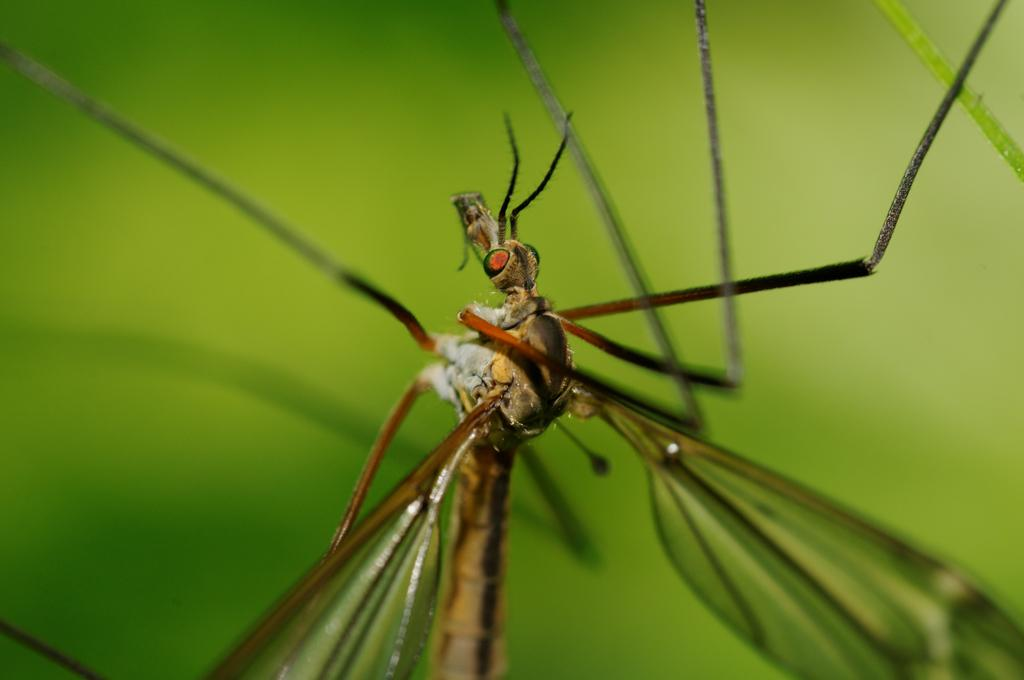What type of creature can be seen in the image? There is an insect in the image. What color is the background of the image? The background of the image is green. What type of feather can be seen on the insect in the image? There is no feather present on the insect in the image. What flavor does the insect have in the image? Insects do not have flavors, and there is no indication of taste in the image. 